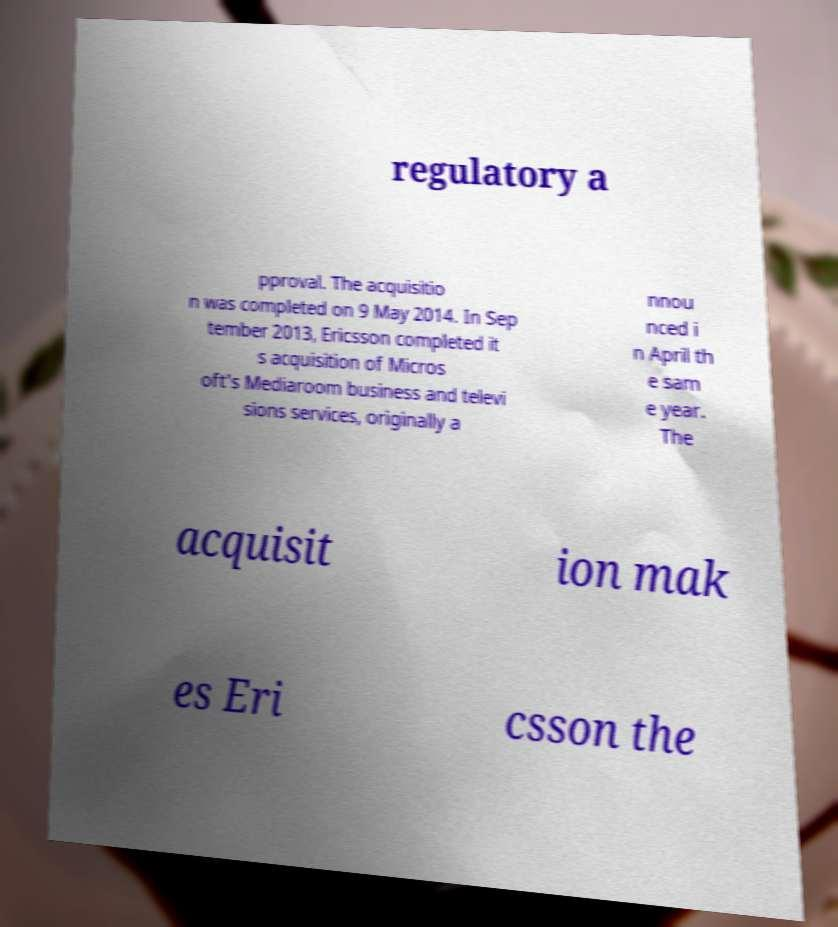I need the written content from this picture converted into text. Can you do that? regulatory a pproval. The acquisitio n was completed on 9 May 2014. In Sep tember 2013, Ericsson completed it s acquisition of Micros oft's Mediaroom business and televi sions services, originally a nnou nced i n April th e sam e year. The acquisit ion mak es Eri csson the 